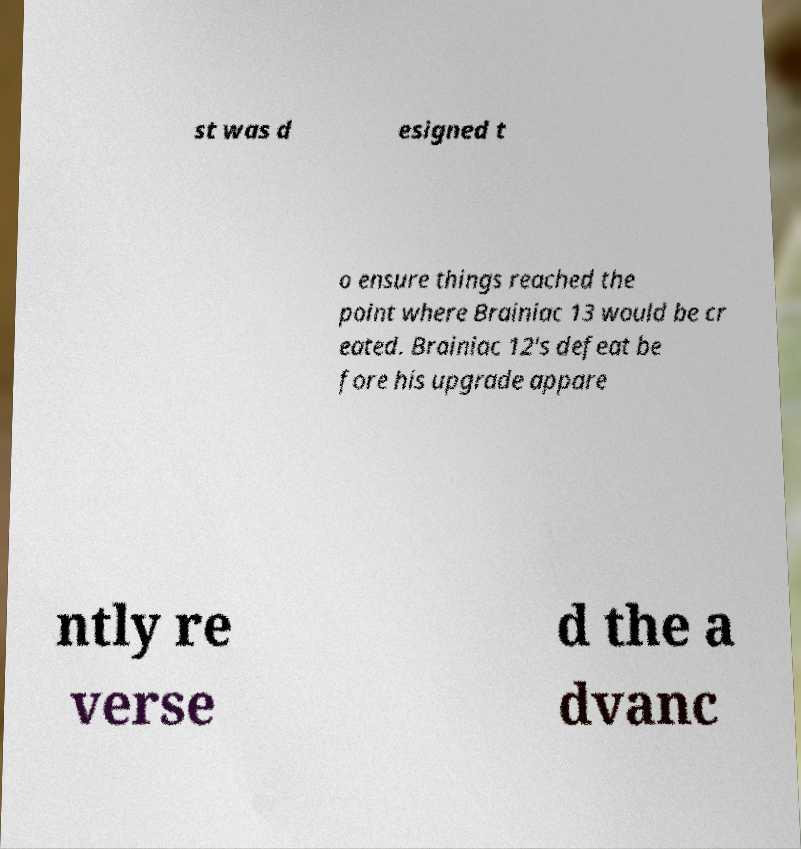I need the written content from this picture converted into text. Can you do that? st was d esigned t o ensure things reached the point where Brainiac 13 would be cr eated. Brainiac 12's defeat be fore his upgrade appare ntly re verse d the a dvanc 